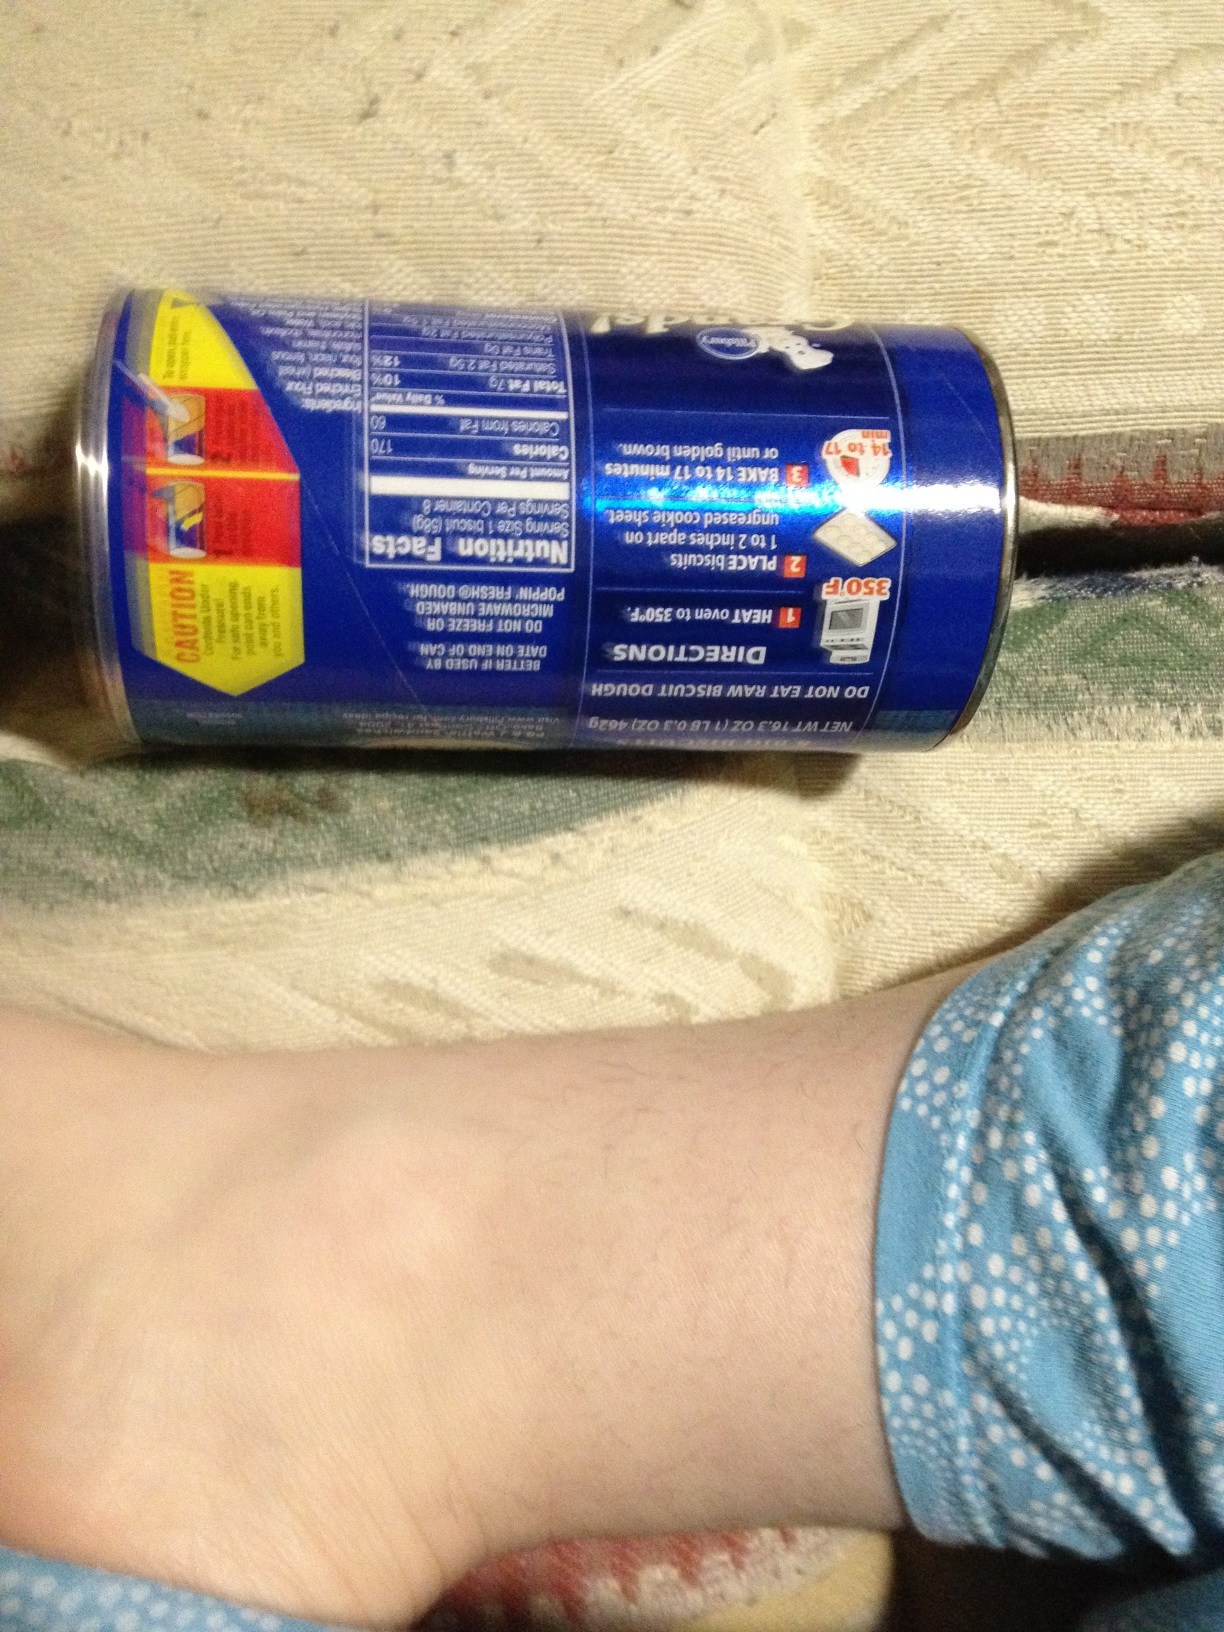Imagine these biscuits are a key ingredient in a mystery novel. How would they be featured? In a gripping mystery novel, these biscuits could be the pivotal clue. The protagonist, a clever detective, notices a trail of biscuit crumbs leading to the hidden location of important evidence. The texture and unique flavor of the biscuit, which is distinctively rare and only sold in specific boutiques, helps narrow down the suspect's location. The biscuits are further analyzed, revealing a particular ingredient found only in a specific region, providing the final key to solve the case. The biscuits, once a simple snack, turn into a breadcrumb trail leading to the unraveling of a complex and thrilling mystery. 